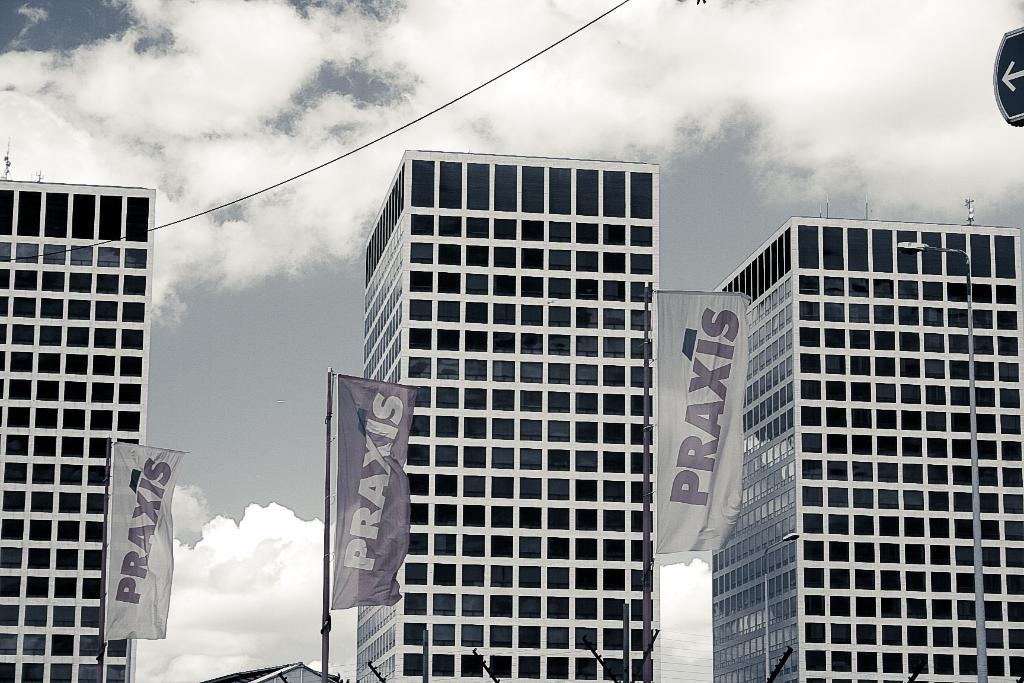What type of structures can be seen in the image? There are buildings in the image. What other objects are present in the image besides buildings? There are flags, wires, poles, and a signboard in the image. What is visible in the sky at the top of the image? There are clouds in the sky at the top of the image. What type of tooth is visible on the signboard in the image? There is no tooth present on the signboard or anywhere else in the image. 